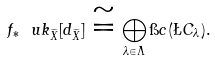Convert formula to latex. <formula><loc_0><loc_0><loc_500><loc_500>f _ { * } \ u k _ { \widetilde { X } } [ d _ { \widetilde { X } } ] \cong \bigoplus _ { \lambda \in \Lambda } \i c ( \L C _ { \lambda } ) .</formula> 